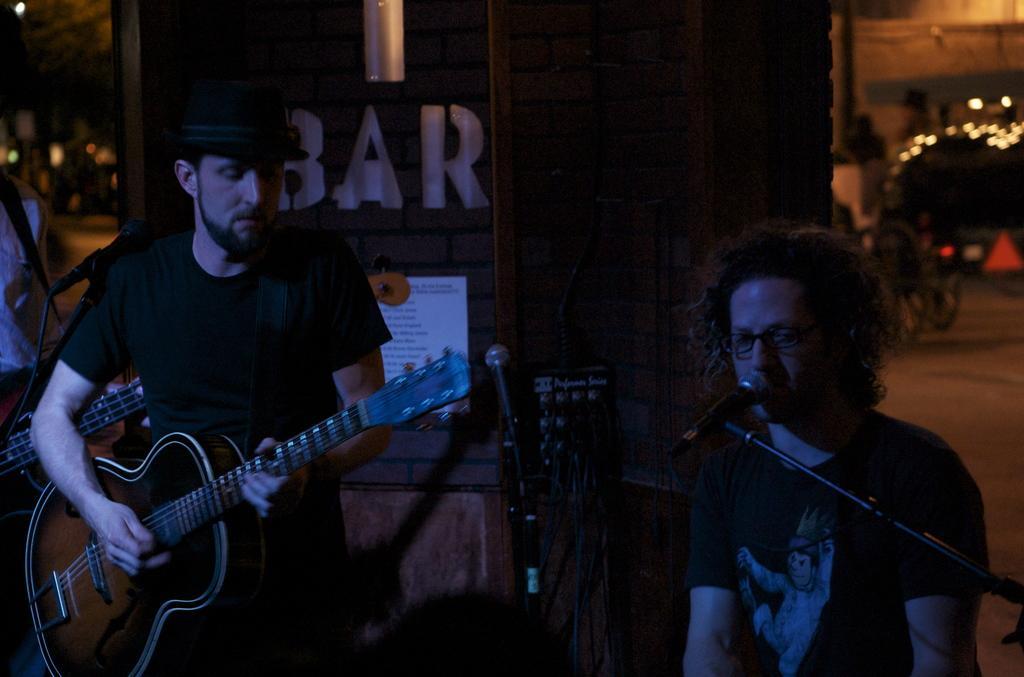Describe this image in one or two sentences. In the right a man is singing a song in the left a boy is playing the guitar. 